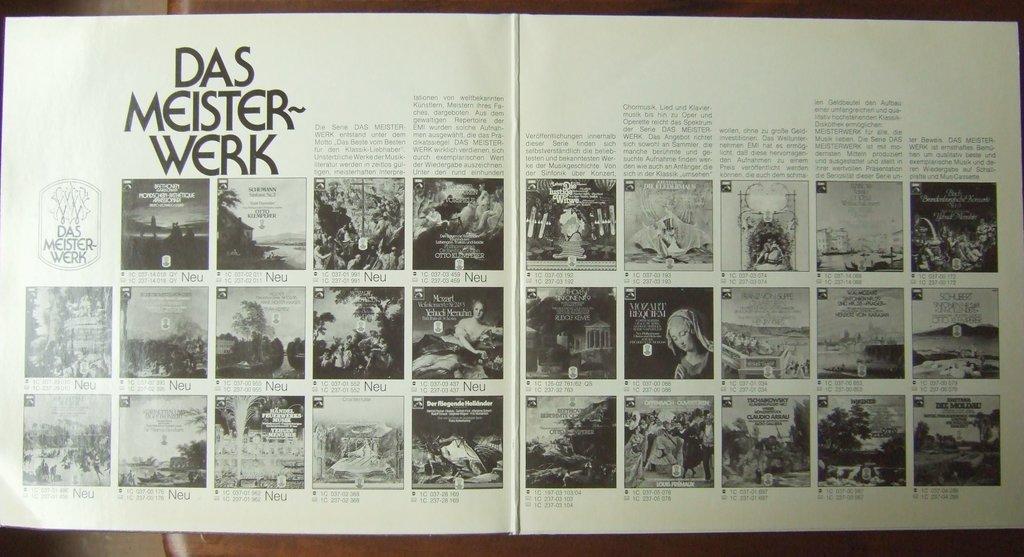First word at the top of the left page?
Your answer should be very brief. Das. What does this page show?
Give a very brief answer. Das meister-werk. 